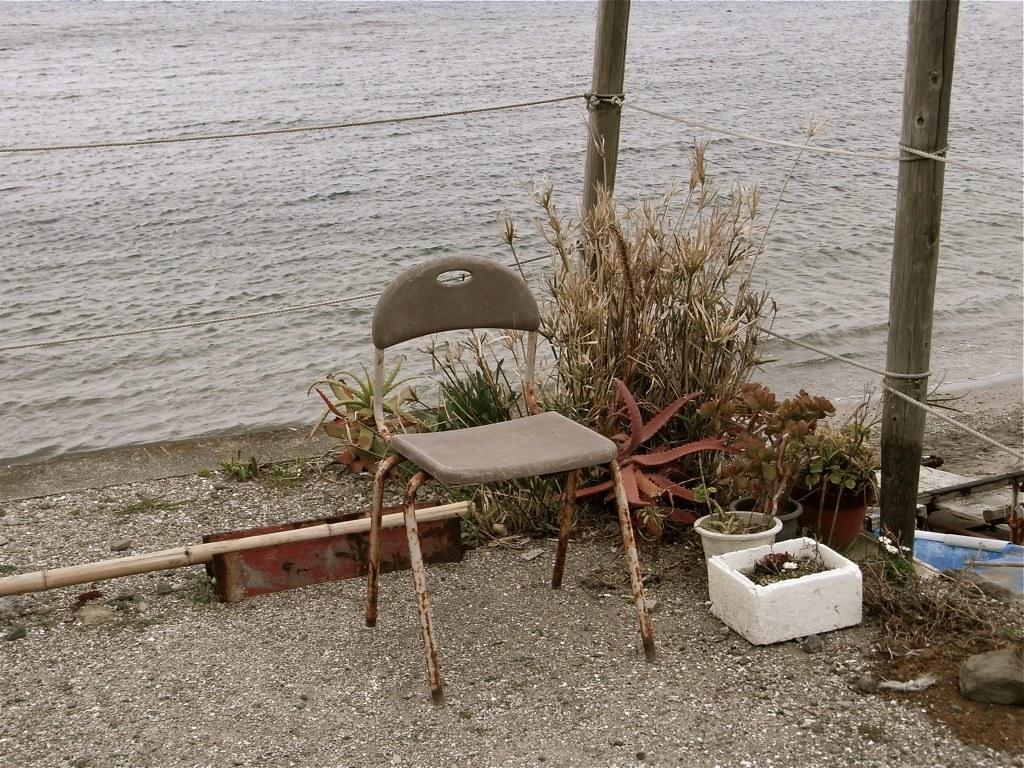What can be seen running through the image? There is a path in the image. What type of furniture is present in the image? There is a chair in the image. What is located near the chair? There are plants near the chair. What is attached to the chair in the image? There are poles and wires tied to the chair. What can be seen in the distance in the image? There is water visible in the background of the image. Is there a flame visible in the image? No, there is no flame present in the image. What type of underground storage space can be seen in the image? There is no cellar present in the image. 